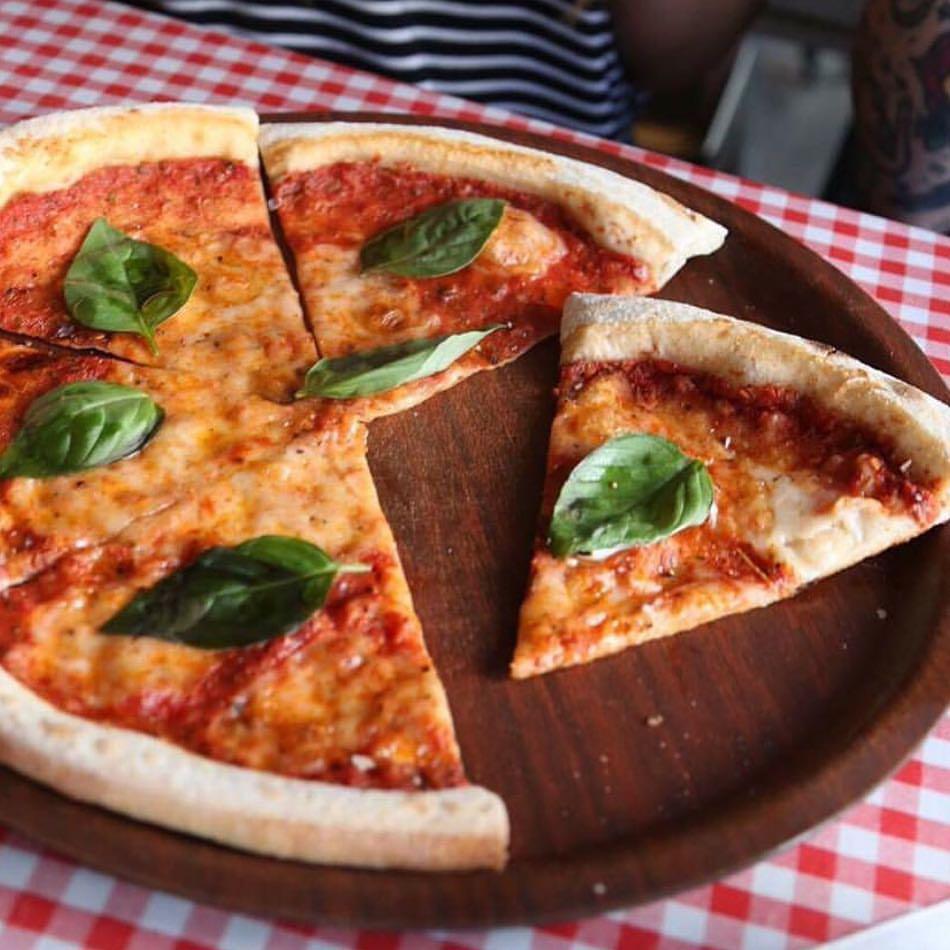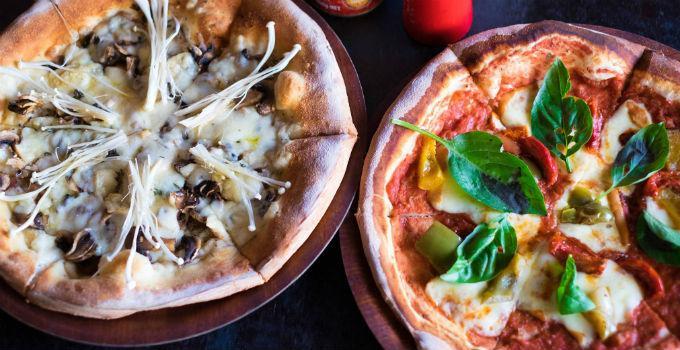The first image is the image on the left, the second image is the image on the right. Analyze the images presented: Is the assertion "The left image contains one pizza on a round wooden tray, which has at least one slice out of place." valid? Answer yes or no. Yes. The first image is the image on the left, the second image is the image on the right. For the images displayed, is the sentence "There are more pizzas in the image on the right." factually correct? Answer yes or no. Yes. 